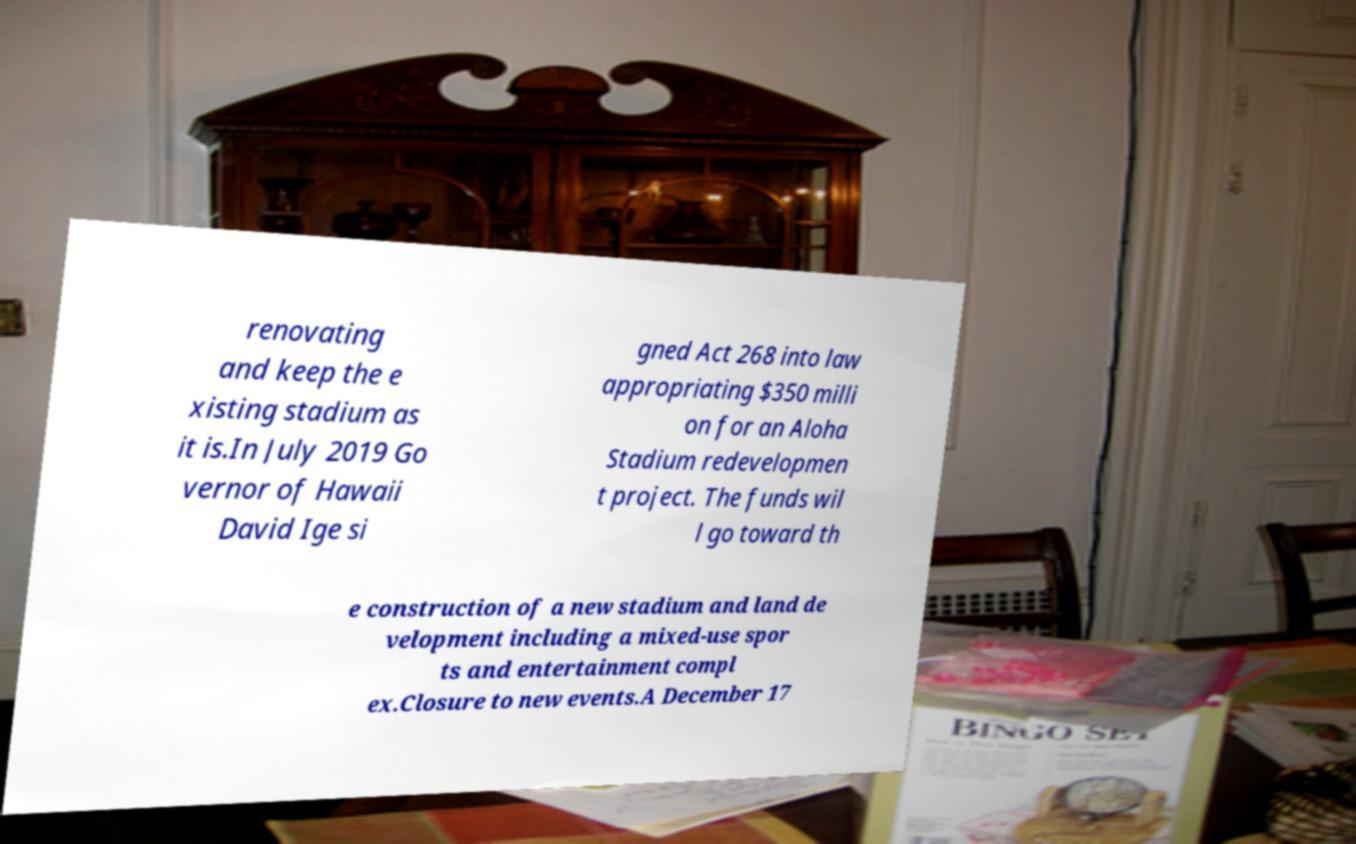Could you extract and type out the text from this image? renovating and keep the e xisting stadium as it is.In July 2019 Go vernor of Hawaii David Ige si gned Act 268 into law appropriating $350 milli on for an Aloha Stadium redevelopmen t project. The funds wil l go toward th e construction of a new stadium and land de velopment including a mixed-use spor ts and entertainment compl ex.Closure to new events.A December 17 